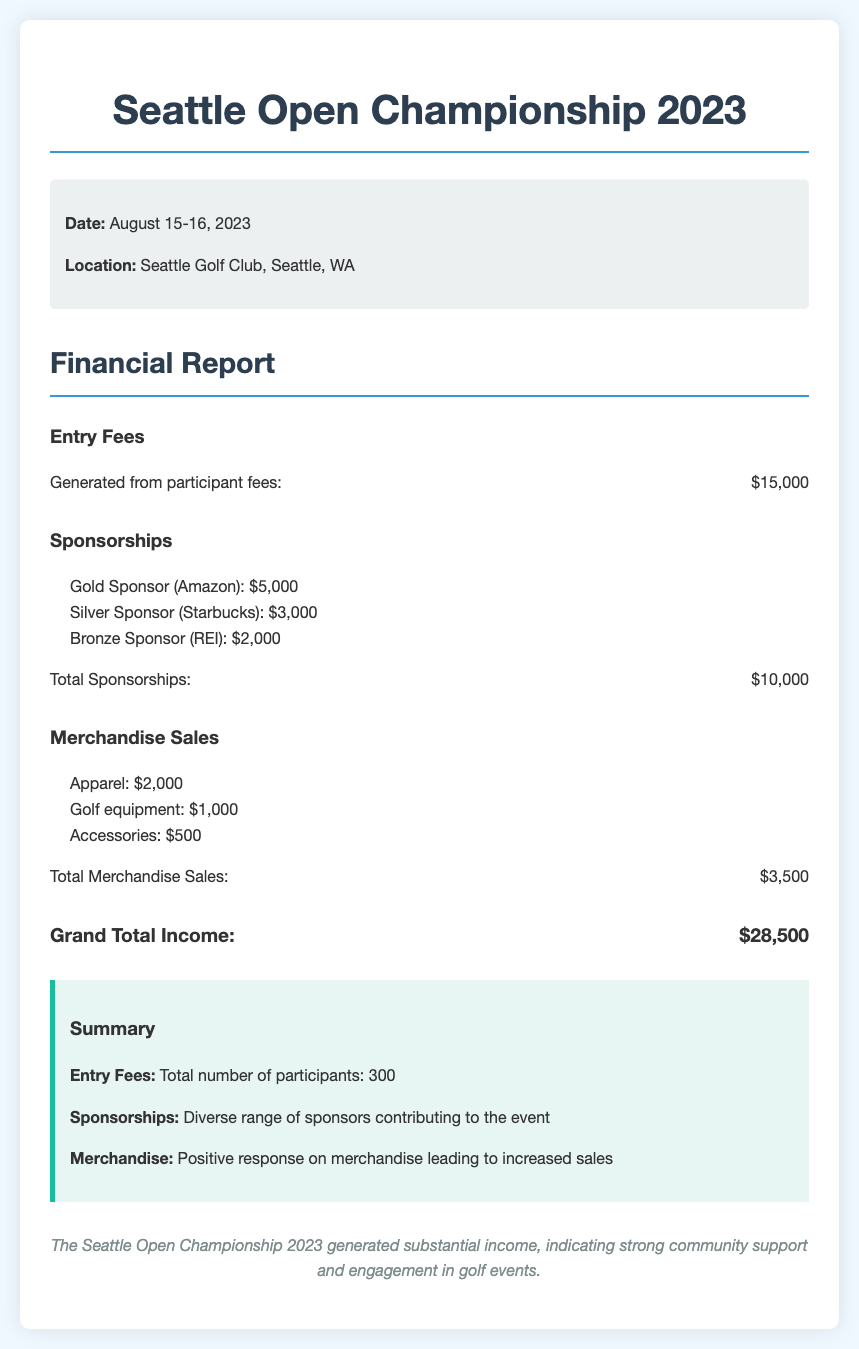What is the date of the Seattle Open Championship 2023? The date is specifically stated in the document as August 15-16, 2023.
Answer: August 15-16, 2023 What is the total generated from entry fees? The entry fees section clearly states the amount generated from participant fees as $15,000.
Answer: $15,000 Who is the Gold Sponsor of the event? The sponsorship section lists Amazon as the Gold Sponsor along with the contribution amount.
Answer: Amazon What is the total amount generated from merchandise sales? The merchandise sales section summarizes the income from merchandise, which amounts to $3,500.
Answer: $3,500 What is the total income generated from sponsorships? The sponsorship section sums up the contributions from all sponsors and shows the total as $10,000.
Answer: $10,000 How many participants were in the event? The summary section mentions the total number of participants as 300.
Answer: 300 What is the Grand Total Income for the tournament? The total income section calculates the Grand Total Income, which is stated as $28,500.
Answer: $28,500 Which company was the Silver Sponsor? The sponsorship list specifically mentions Starbucks as the Silver Sponsor along with the contribution amount.
Answer: Starbucks What merchandise category generated the highest sales? The merchandise sales section indicates that Apparel generated the highest sales at $2,000.
Answer: Apparel 